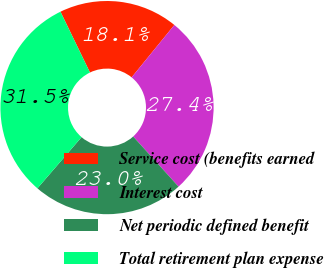<chart> <loc_0><loc_0><loc_500><loc_500><pie_chart><fcel>Service cost (benefits earned<fcel>Interest cost<fcel>Net periodic defined benefit<fcel>Total retirement plan expense<nl><fcel>18.08%<fcel>27.41%<fcel>23.03%<fcel>31.49%<nl></chart> 